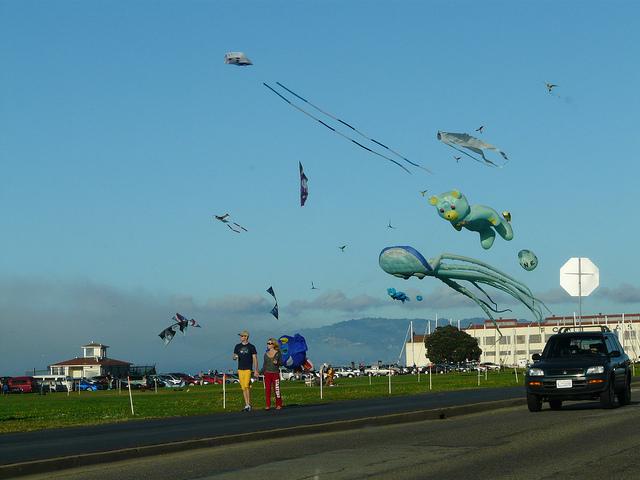What are flying?
Write a very short answer. Kites. Where is the octopus in relation to the bear?
Short answer required. Below. Is a car moving?
Concise answer only. Yes. 